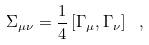Convert formula to latex. <formula><loc_0><loc_0><loc_500><loc_500>\Sigma _ { \mu \nu } = \frac { 1 } { 4 } \left [ \Gamma _ { \mu } , \Gamma _ { \nu } \right ] \ ,</formula> 